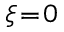<formula> <loc_0><loc_0><loc_500><loc_500>\xi \, = \, 0</formula> 